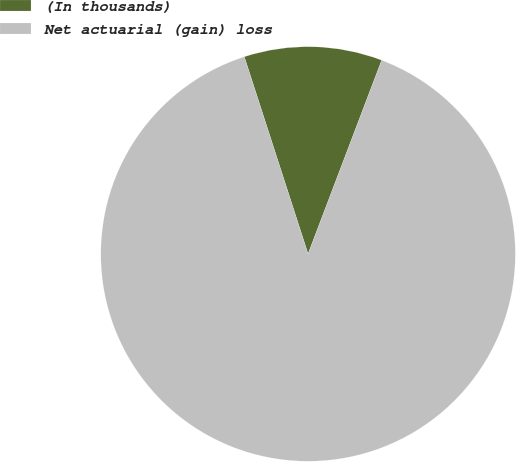Convert chart to OTSL. <chart><loc_0><loc_0><loc_500><loc_500><pie_chart><fcel>(In thousands)<fcel>Net actuarial (gain) loss<nl><fcel>10.76%<fcel>89.24%<nl></chart> 